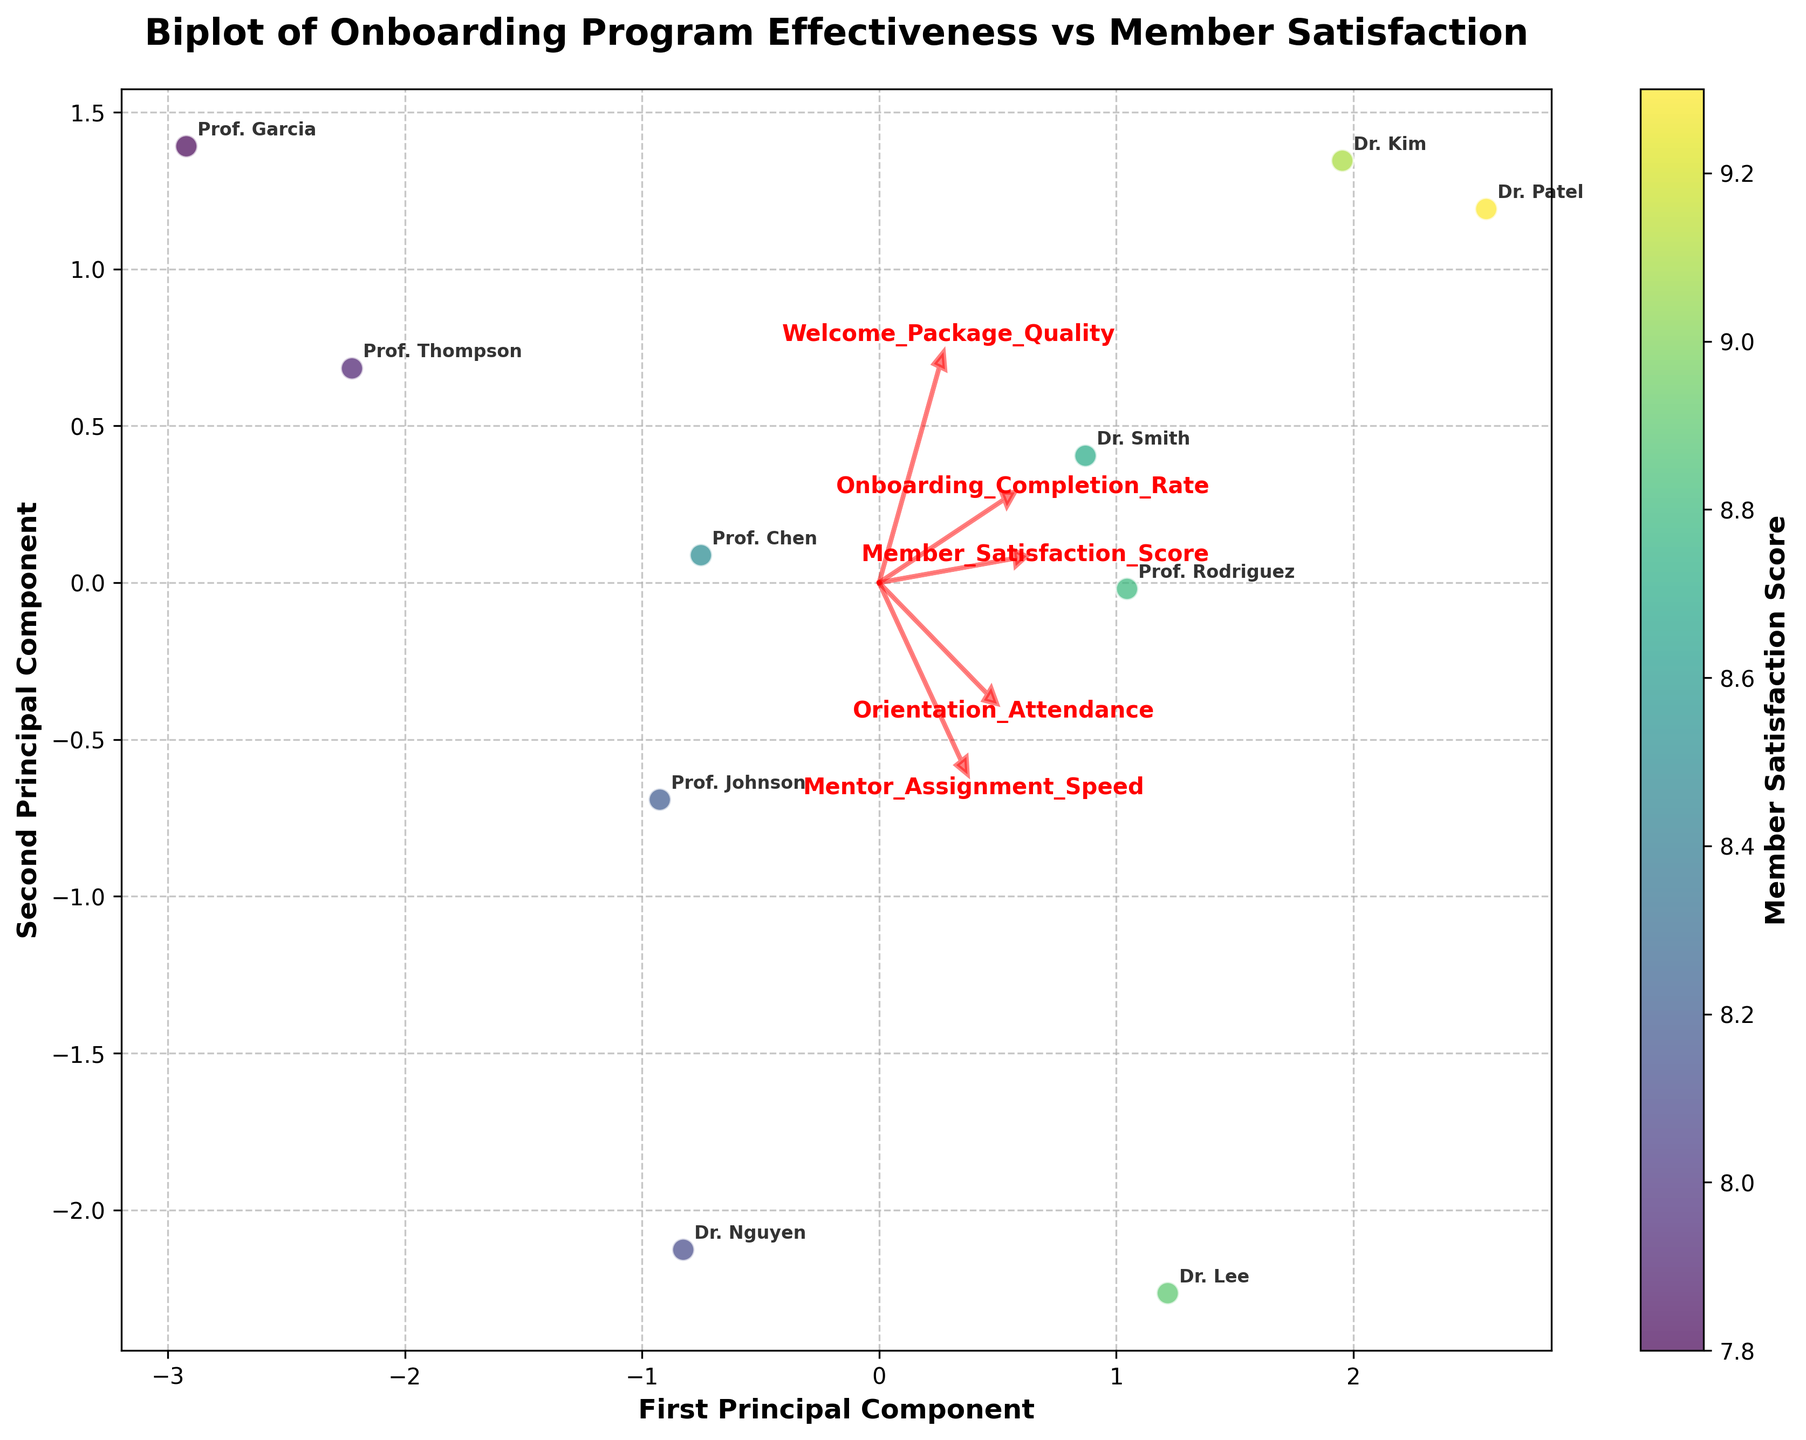Does Prof. Thompson have a high Member Satisfaction Score? The color of the points in the scatterplot represents the Member Satisfaction Score. Prof. Thompson's point is located toward the bottom left side of the graph and appears less saturated, indicating a lower satisfaction score.
Answer: No Which member has the highest Onboarding Completion Rate? The vector for Onboarding Completion Rate is shown as one of the red arrows. The furthest point in the positive direction of this vector will represent the highest Onboarding Completion Rate. Dr. Patel's point is the furthest in this direction.
Answer: Dr. Patel How do Member Satisfaction Scores generally relate to Mentor Assignment Speed? To assess the relationship between Member Satisfaction Scores and Mentor Assignment Speed, we'd look at the direction of the vectors for these features. If they are pointing in similar directions, it means a positive correlation. Here, their vectors point relatively similar, suggesting a positive relationship.
Answer: Positive correlation Which member has the lowest score for Orientation Attendance? By identifying the vector direction for Orientation Attendance and finding the point that is furthest in the opposite direction to this vector, we can determine the member with the lowest score. Prof. Garcia's point is furthest in the opposite direction.
Answer: Prof. Garcia Which two members appear to have the most similar onboarding assessment and satisfaction profiles? Two members would have similar profiles if their points on the scatterplot are close to each other. The points for Dr. Smith and Dr. Kim are very close to each other, indicating similar profiles.
Answer: Dr. Smith and Dr. Kim What is the significance of the color gradient used in the plot? The color gradient in the scatter plot represents the Member Satisfaction Score, with different shades indicating different levels of satisfaction. Darker shades correspond to higher satisfaction scores and lighter shades to lower satisfaction scores.
Answer: Member Satisfaction Score Where does Prof. Johnson stand in terms of Welcome Package Quality? Prof. Johnson's point can be placed in the context of the Welcome Package Quality vector. Since vectors indicate positive direction, and Prof. Johnson's point is medium along this vector, Prof. Johnson has an above-average Welcome Package Quality.
Answer: Above average Would you say there is a strong isolation pattern of member points based on their satisfaction scores? The plot shows whether points are clustered together or scattered across the space. If points are tightly clustered, members have similar satisfaction scores and onboarding experiences. A scattered pattern means variability. Here, the points are somewhat spread out, suggesting variability.
Answer: No strong isolation How does Welcome Package Quality influence Member Satisfaction Scores in this dataset? By examining the alignment and direction of the vectors for Welcome Package Quality and Member Satisfaction Scores, we see they point in similar directions. This alignment suggests that higher Welcome Package Quality generally leads to higher Member Satisfaction Scores.
Answer: Positive influence Which variable appears to contribute most to the first principal component in this PCA analysis? The length and direction of vectors regarding the first principal component axis indicate contributions. The 'Onboarding Completion Rate' vector is significantly longer and points most in the direction of the first principal axis, indicating it is the most contributory variable.
Answer: Onboarding Completion Rate 